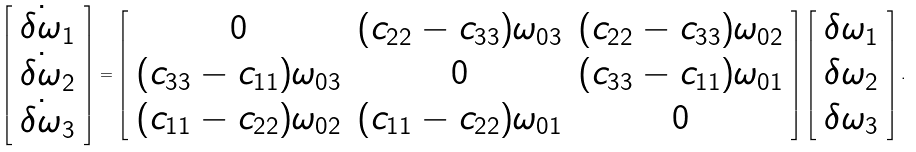Convert formula to latex. <formula><loc_0><loc_0><loc_500><loc_500>\left [ \begin{array} { c } \dot { \delta \omega } _ { 1 } \\ \dot { \delta \omega } _ { 2 } \\ \dot { \delta \omega } _ { 3 } \end{array} \right ] = \left [ \begin{array} { c c c } 0 & ( c _ { 2 2 } - c _ { 3 3 } ) \omega _ { 0 3 } & ( c _ { 2 2 } - c _ { 3 3 } ) \omega _ { 0 2 } \\ ( c _ { 3 3 } - c _ { 1 1 } ) \omega _ { 0 3 } & 0 & ( c _ { 3 3 } - c _ { 1 1 } ) \omega _ { 0 1 } \\ ( c _ { 1 1 } - c _ { 2 2 } ) \omega _ { 0 2 } & ( c _ { 1 1 } - c _ { 2 2 } ) \omega _ { 0 1 } & 0 \end{array} \right ] \left [ \begin{array} { c } \delta \omega _ { 1 } \\ \delta \omega _ { 2 } \\ \delta \omega _ { 3 } \end{array} \right ] .</formula> 